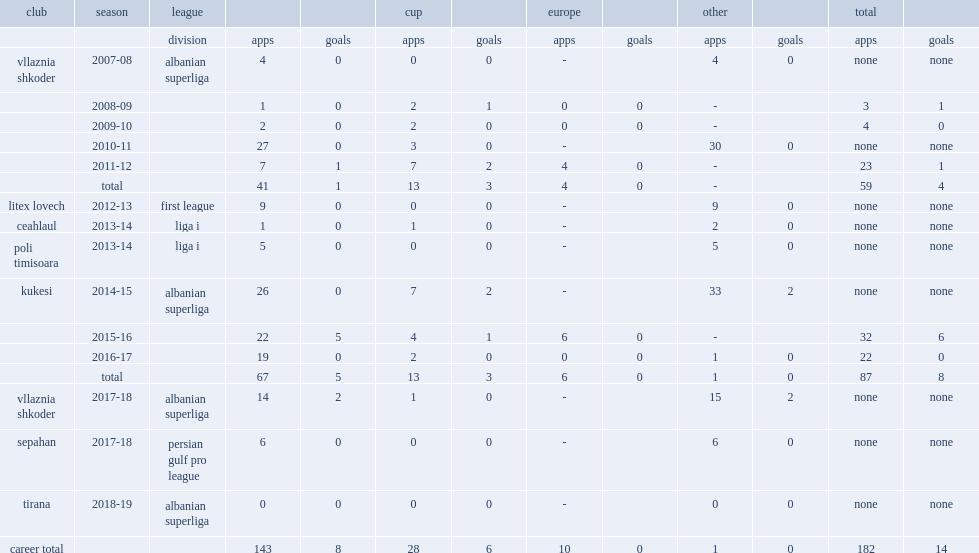Which club did hasani play for in 2014-15? Kukesi. 